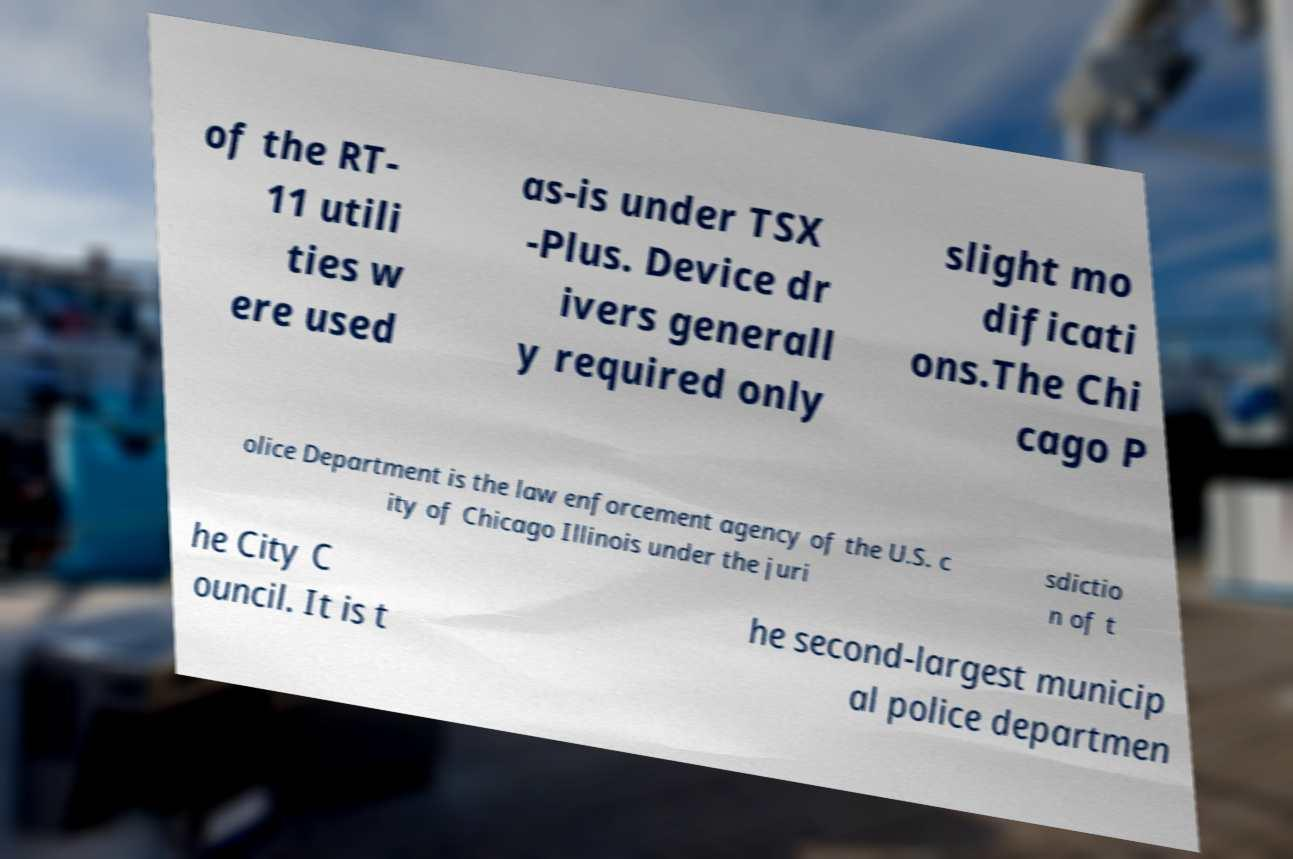Can you read and provide the text displayed in the image?This photo seems to have some interesting text. Can you extract and type it out for me? of the RT- 11 utili ties w ere used as-is under TSX -Plus. Device dr ivers generall y required only slight mo dificati ons.The Chi cago P olice Department is the law enforcement agency of the U.S. c ity of Chicago Illinois under the juri sdictio n of t he City C ouncil. It is t he second-largest municip al police departmen 